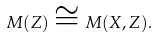Convert formula to latex. <formula><loc_0><loc_0><loc_500><loc_500>M ( Z ) \cong M ( X , Z ) .</formula> 